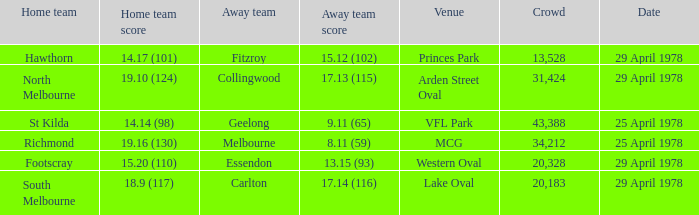Who was the home team at MCG? Richmond. 